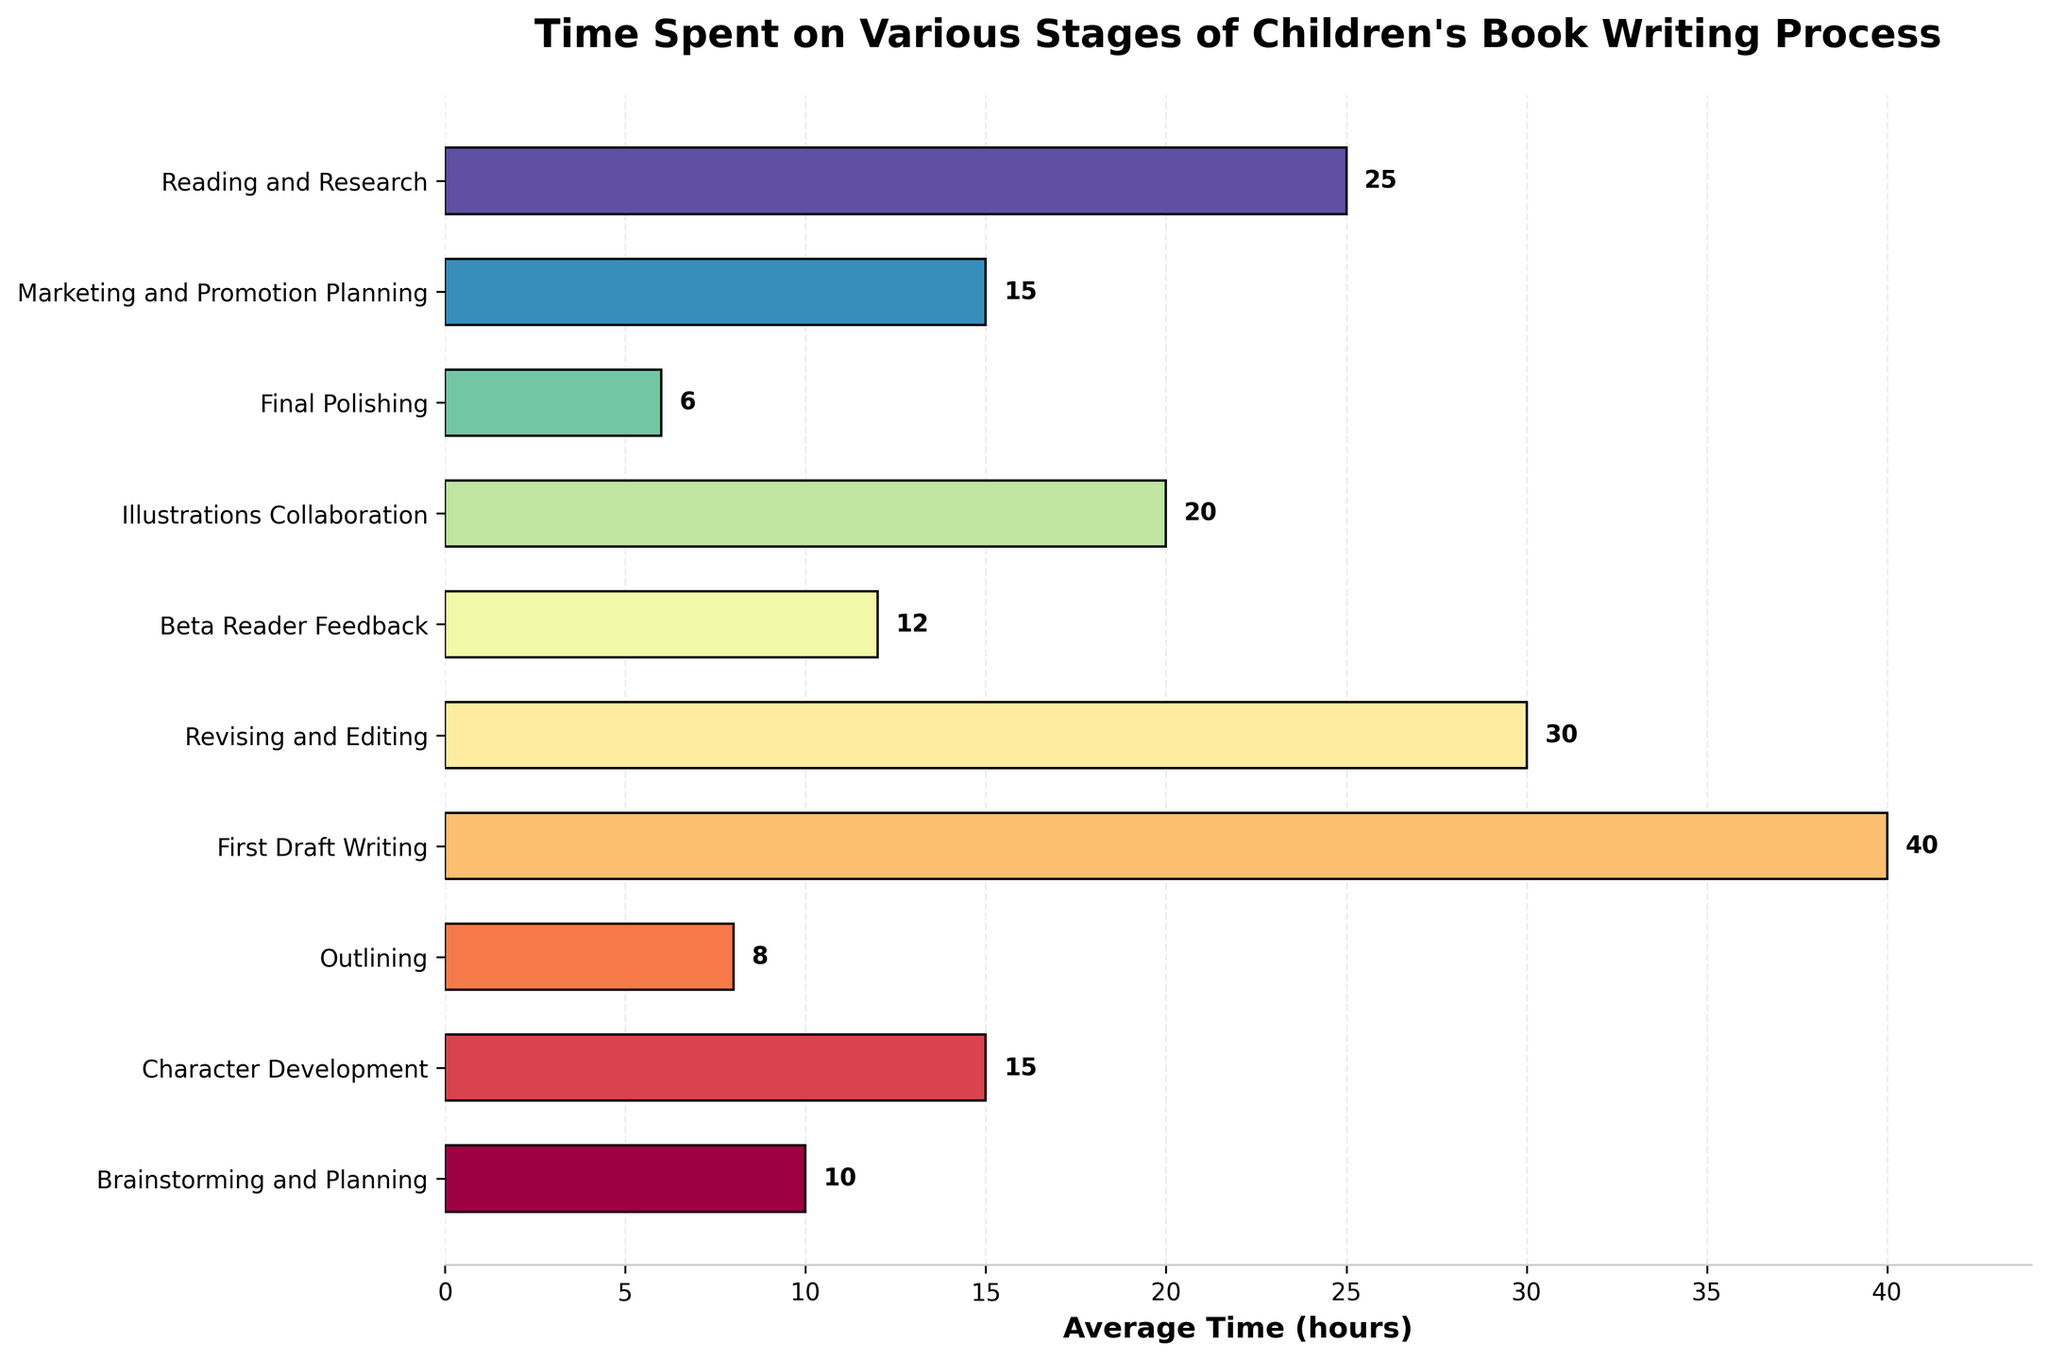What activity takes the most amount of time? The highest bar in the graph represents the stage that takes the most time. The "First Draft Writing" stage has a bar extending to 40 hours, making it the longest.
Answer: First Draft Writing Which stage requires the least amount of time? The shortest bar represents the shortest stage. The "Final Polishing" stage has a bar extending to only 6 hours, making it the shortest stage.
Answer: Final Polishing How much time is spent in total for Brainstorming and Planning and Character Development? Add the times for the "Brainstorming and Planning" (10 hours) and "Character Development" (15 hours) stages. 10 + 15 = 25 hours.
Answer: 25 hours What is the difference in time spent between Revising and Editing and Illustrations Collaboration? Subtract the time spent on "Illustrations Collaboration" (20 hours) from the time spent on "Revising and Editing" (30 hours). 30 - 20 = 10 hours.
Answer: 10 hours Which stages take an equal amount of time? Visually identify bars of equal length. Both "Character Development" and "Marketing and Promotion Planning" take 15 hours each, as their bars extend to the same point.
Answer: Character Development and Marketing and Promotion Planning Among all stages, where does Marketing and Promotion Planning rank in terms of time spent? Compare the bar lengths to rank the stages by length. Marketing and Promotion Planning (15 hours) ranks 5th when sorted in descending order of time spent.
Answer: 5th What's the combined time spent on Marketing and Promotion Planning, Reading and Research, and Beta Reader Feedback? Add the hours: "Marketing and Promotion Planning" (15), "Reading and Research" (25), and "Beta Reader Feedback" (12). 15 + 25 + 12 = 52 hours.
Answer: 52 hours If you add the time for Outlining and Final Polishing, does it exceed Reading and Research? Add the hours for "Outlining" (8) and "Final Polishing" (6). 8 + 6 = 14 hours. Compare it to "Reading and Research" (25 hours). 14 < 25, so it does not exceed.
Answer: No Do Beta Reader Feedback and Outlining combined take more time than Character Development? Add the hours for "Beta Reader Feedback" (12) and "Outlining" (8). 12 + 8 = 20 hours. Compare it to "Character Development" (15 hours). 20 > 15, so it takes more time.
Answer: Yes 